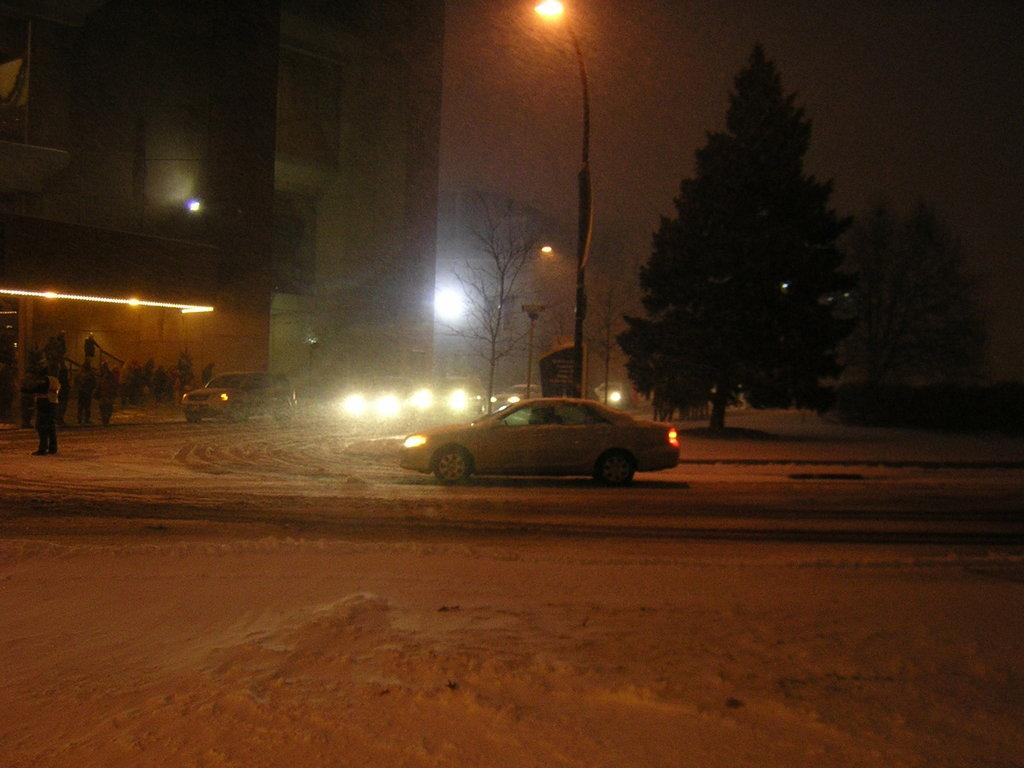What can be seen on the road in the image? There are vehicles on the road in the image. Who or what else is present in the image? There are people in the image. What can be seen in the distance in the image? There are buildings, trees, lights, and the sky visible in the background of the image. What is the tendency of the flavor in the image? There is no mention of flavor in the image, as it features vehicles, people, buildings, trees, lights, and the sky. What mark can be seen on the people in the image? There is no mention of a mark on the people in the image; they are not described in any detail. 